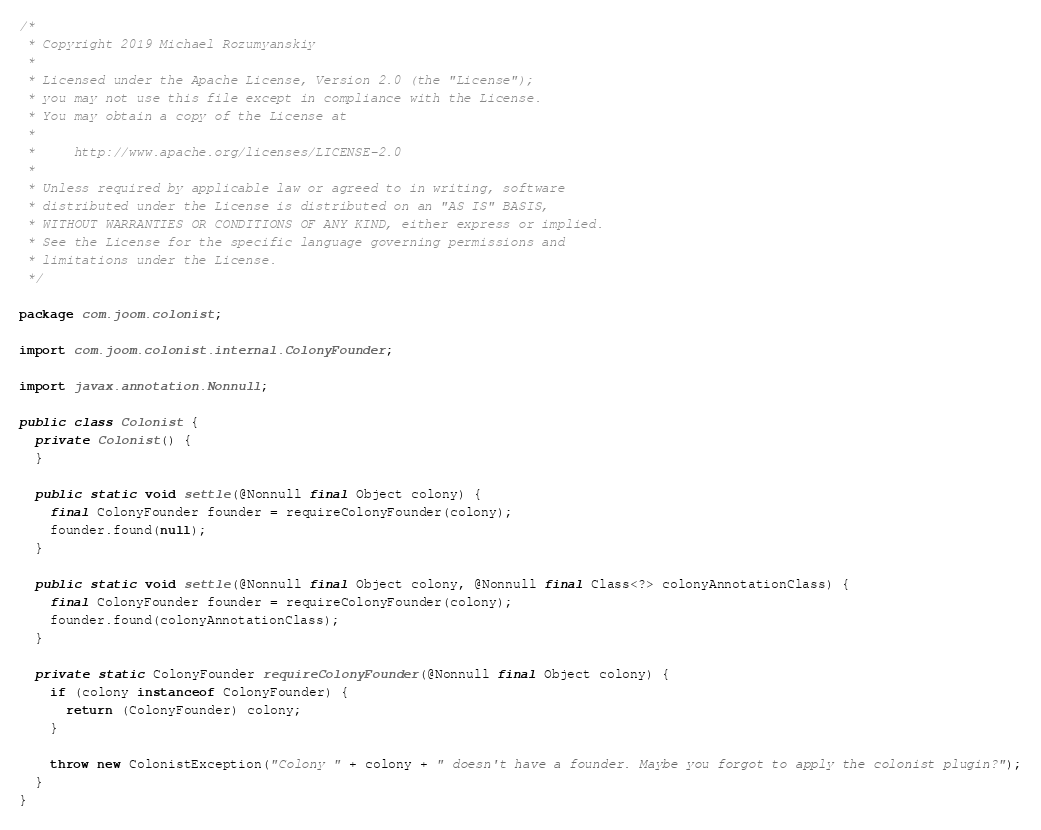<code> <loc_0><loc_0><loc_500><loc_500><_Java_>/*
 * Copyright 2019 Michael Rozumyanskiy
 *
 * Licensed under the Apache License, Version 2.0 (the "License");
 * you may not use this file except in compliance with the License.
 * You may obtain a copy of the License at
 *
 *     http://www.apache.org/licenses/LICENSE-2.0
 *
 * Unless required by applicable law or agreed to in writing, software
 * distributed under the License is distributed on an "AS IS" BASIS,
 * WITHOUT WARRANTIES OR CONDITIONS OF ANY KIND, either express or implied.
 * See the License for the specific language governing permissions and
 * limitations under the License.
 */

package com.joom.colonist;

import com.joom.colonist.internal.ColonyFounder;

import javax.annotation.Nonnull;

public class Colonist {
  private Colonist() {
  }

  public static void settle(@Nonnull final Object colony) {
    final ColonyFounder founder = requireColonyFounder(colony);
    founder.found(null);
  }

  public static void settle(@Nonnull final Object colony, @Nonnull final Class<?> colonyAnnotationClass) {
    final ColonyFounder founder = requireColonyFounder(colony);
    founder.found(colonyAnnotationClass);
  }

  private static ColonyFounder requireColonyFounder(@Nonnull final Object colony) {
    if (colony instanceof ColonyFounder) {
      return (ColonyFounder) colony;
    }

    throw new ColonistException("Colony " + colony + " doesn't have a founder. Maybe you forgot to apply the colonist plugin?");
  }
}
</code> 